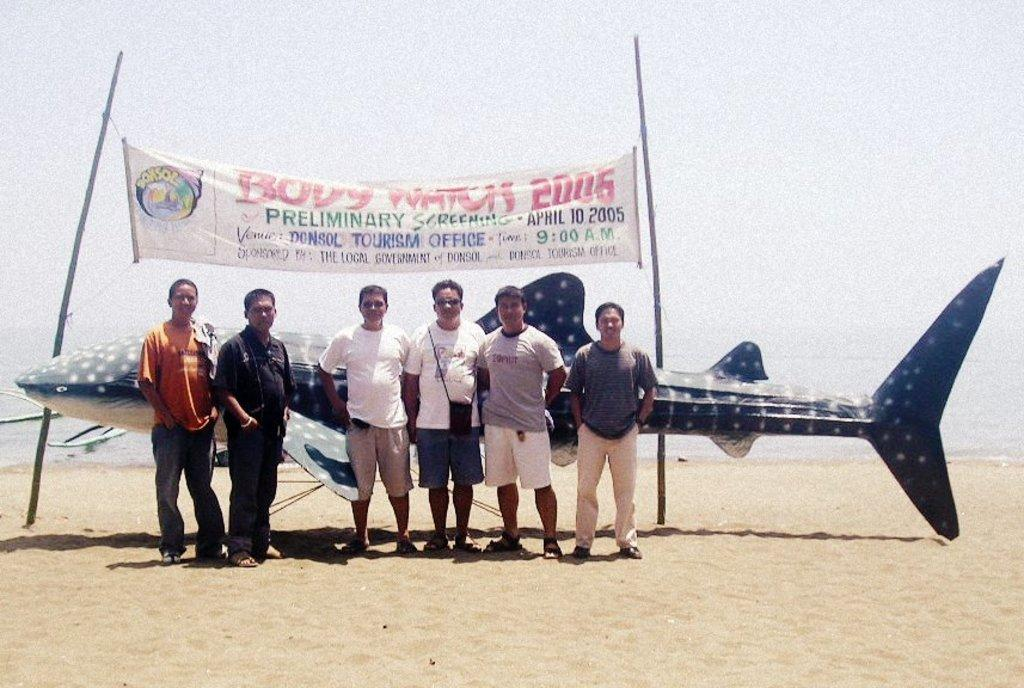<image>
Give a short and clear explanation of the subsequent image. People stand in front of a display made by the tourism office. 